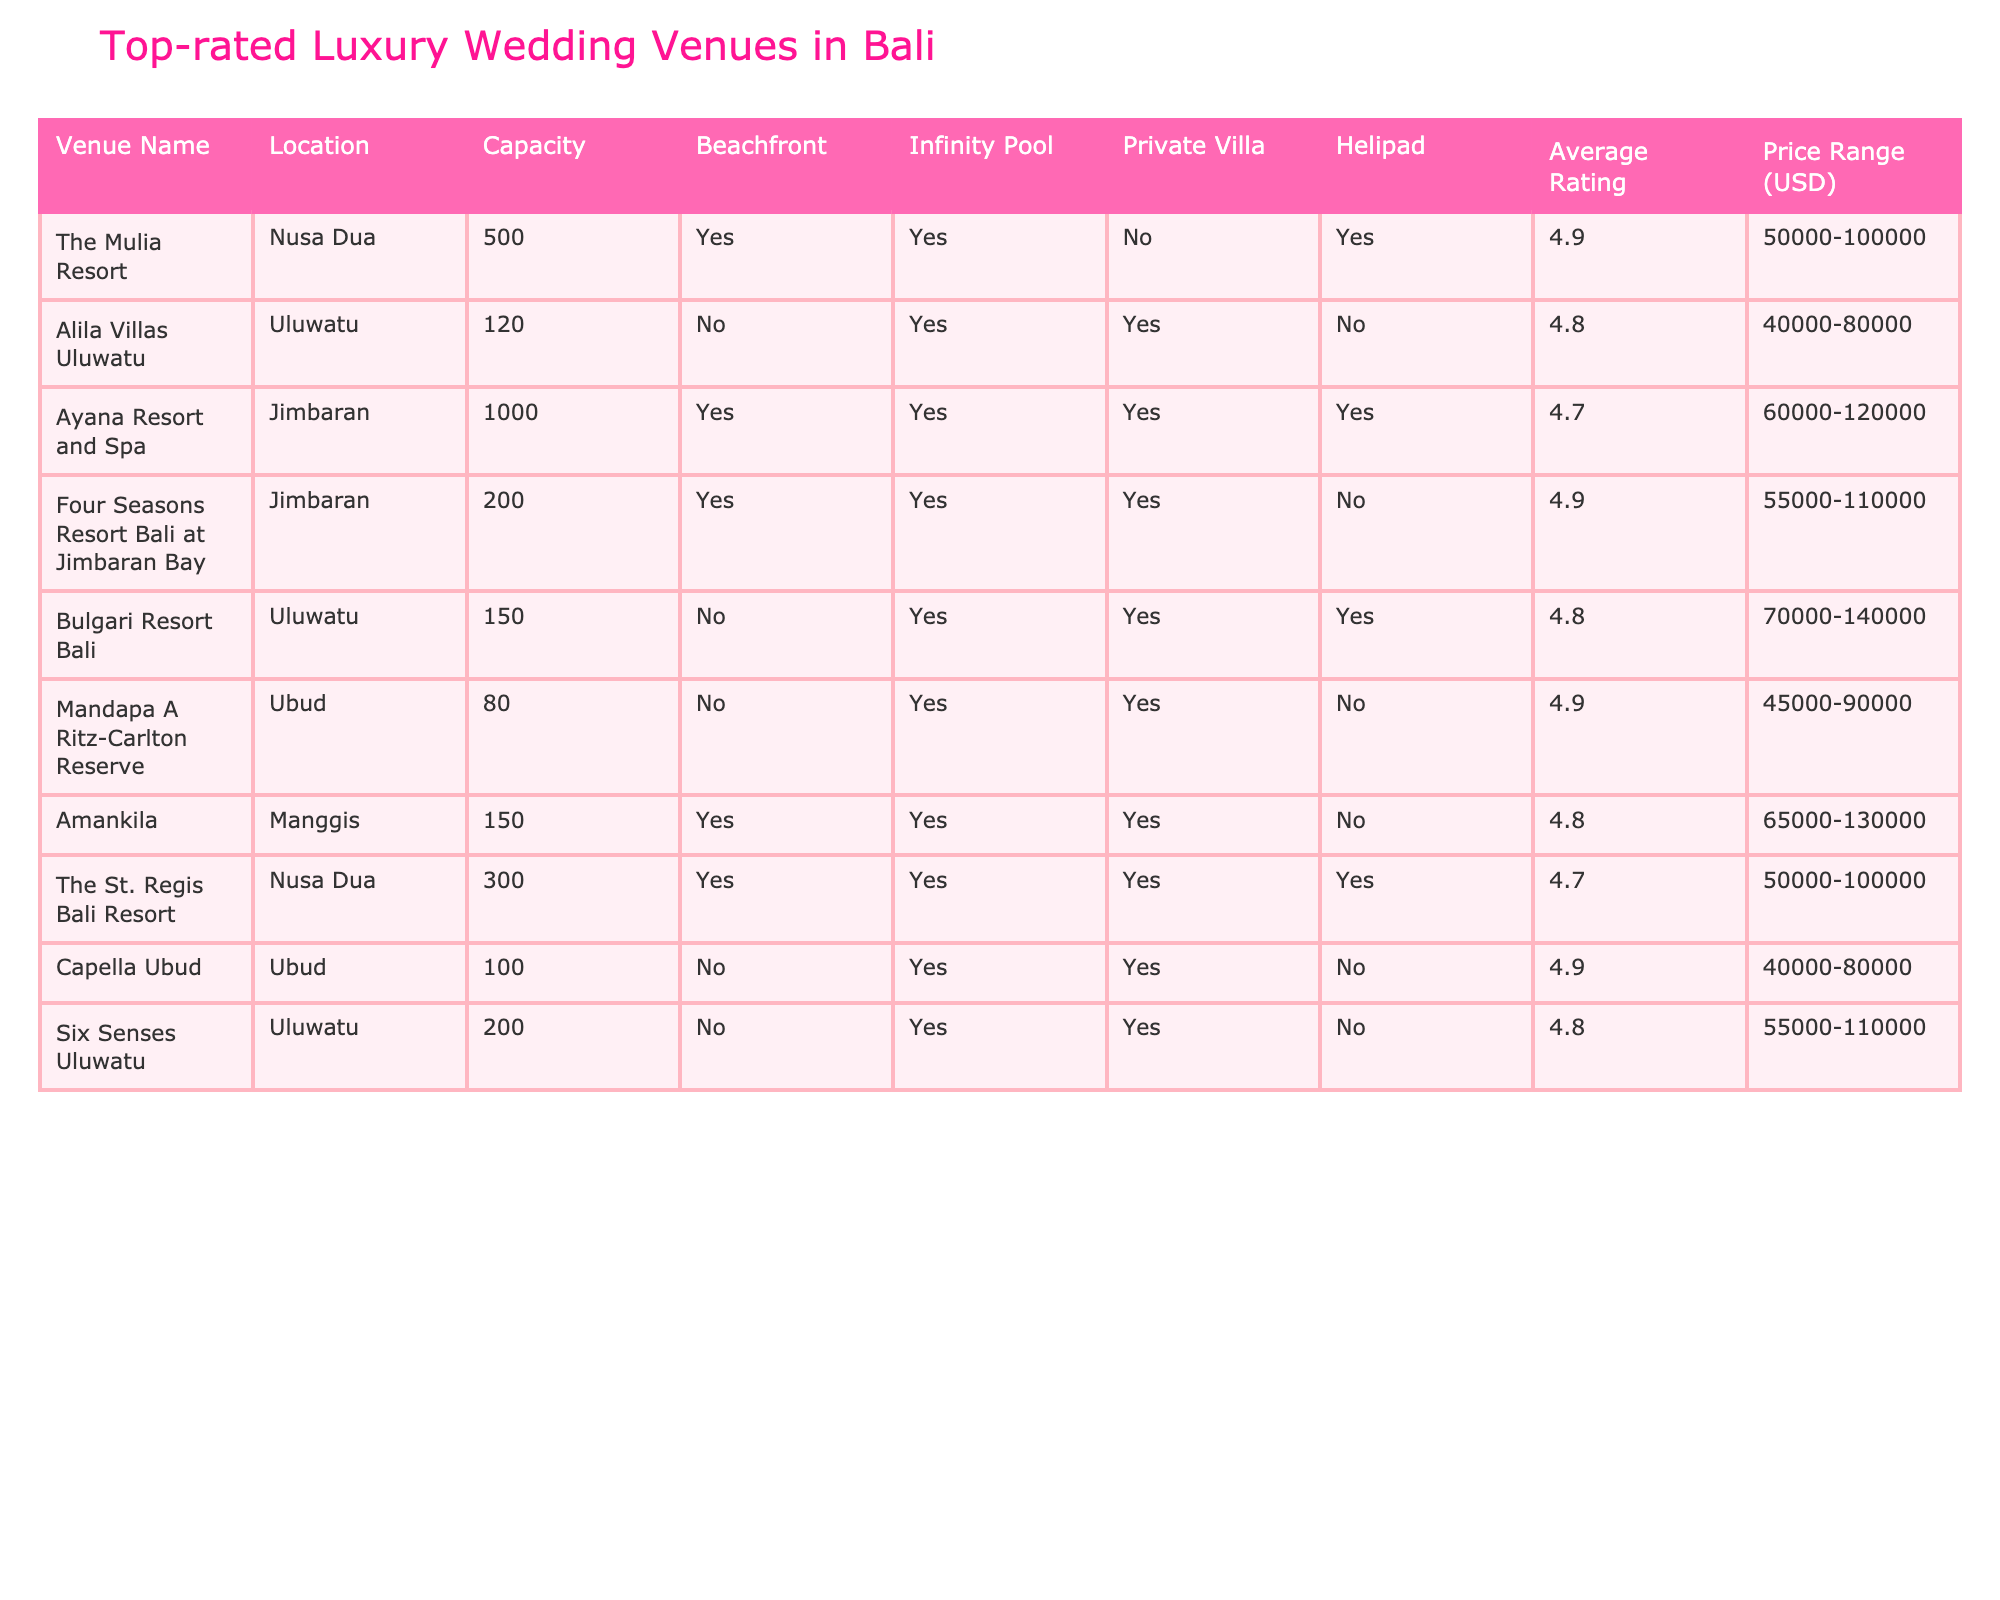What is the maximum capacity of a venue listed in the table? The maximum capacity is found by identifying the highest number in the Capacity column. The Ayana Resort and Spa has the highest capacity at 1000 guests.
Answer: 1000 Which venue has the highest average rating? The average ratings are compared from the Average Rating column. The Mulia Resort and Four Seasons Resort Bali at Jimbaran Bay both have the highest rating of 4.9.
Answer: The Mulia Resort and Four Seasons Resort Bali at Jimbaran Bay How many venues have a helipad? To answer this, I count the "Yes" responses in the Helipad column. The following venues have a helipad: Ayana Resort and Spa, Bulgari Resort Bali, and The St. Regis Bali Resort, which totals three.
Answer: 3 What is the price range for The St. Regis Bali Resort? You can find the price range directly in the Price Range column under The St. Regis Bali Resort entry. The price range is 50,000 to 100,000 USD.
Answer: 50,000-100,000 USD Is there a venue that offers both a beachfront and private villa? To determine this, check the Beachfront and Private Villa columns. The Ayana Resort and Spa and The St. Regis Bali Resort both offer a beachfront and private villa.
Answer: Yes What is the average price range of all venues listed? First, I need to calculate the average for each price range by finding the midpoint of each range, then summing these values and dividing by the number of venues. The calculated averages result in an approximate average price range of 56,250 USD.
Answer: 56,250 USD Which venue has the lowest capacity and still has an infinity pool? The Capacity column must be reviewed for venues that have "Yes" under Infinity Pool. The venue Capella Ubud has the lowest capacity of 100 with an infinity pool.
Answer: Capella Ubud Do all venues offer private villas? Review the Private Villa column for each venue to check the responses. Not all venues offer private villas as confirmed by Ayana Resort and Spa, and The Mulia Resort which do not have a private villa option.
Answer: No 